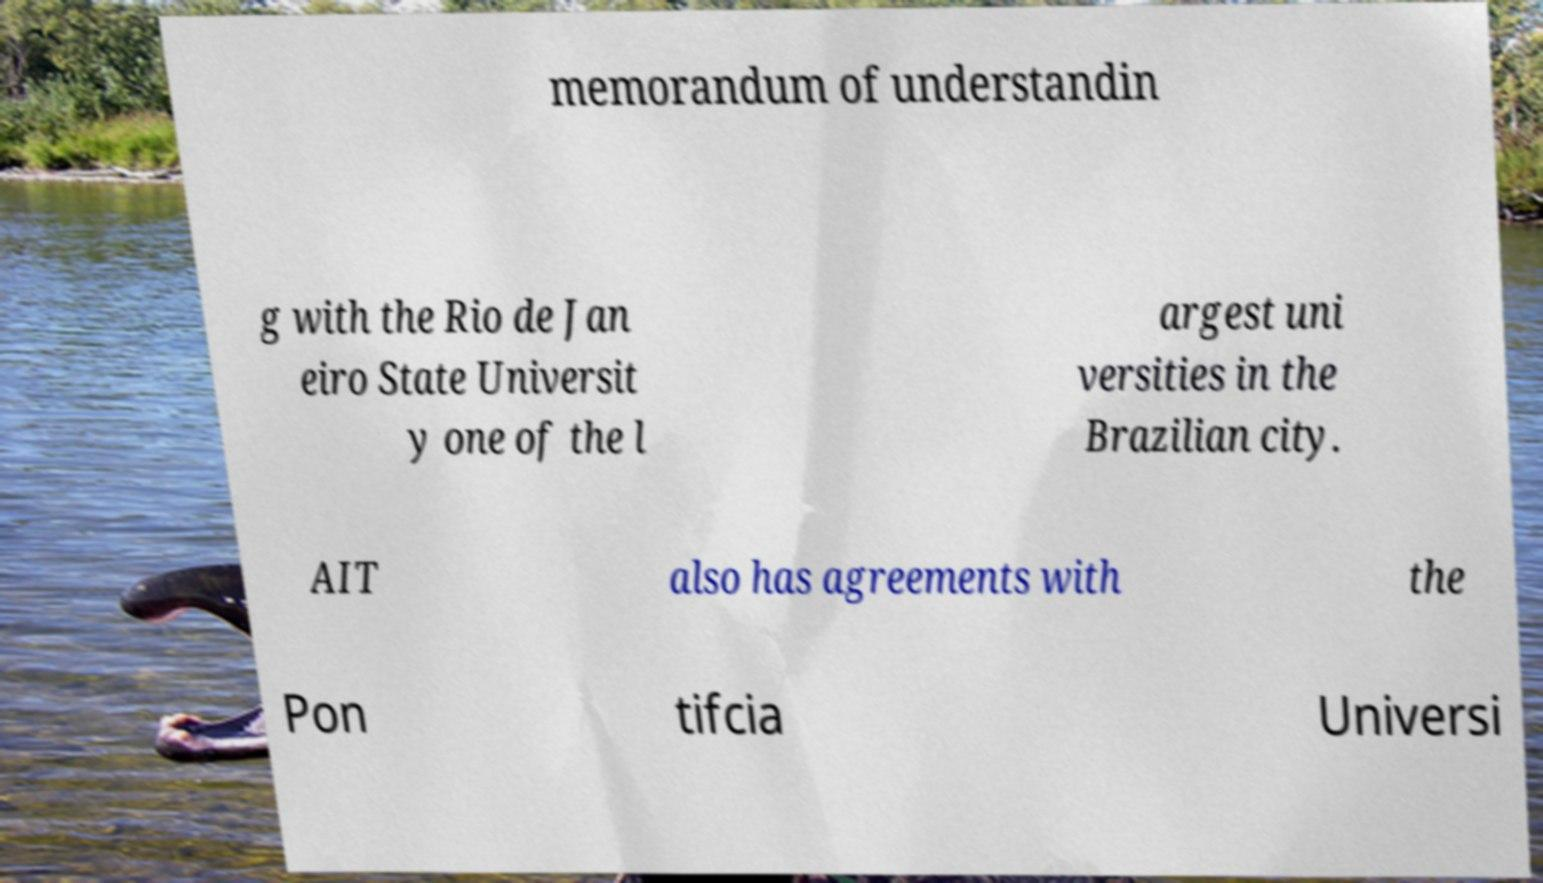Could you assist in decoding the text presented in this image and type it out clearly? memorandum of understandin g with the Rio de Jan eiro State Universit y one of the l argest uni versities in the Brazilian city. AIT also has agreements with the Pon tifcia Universi 